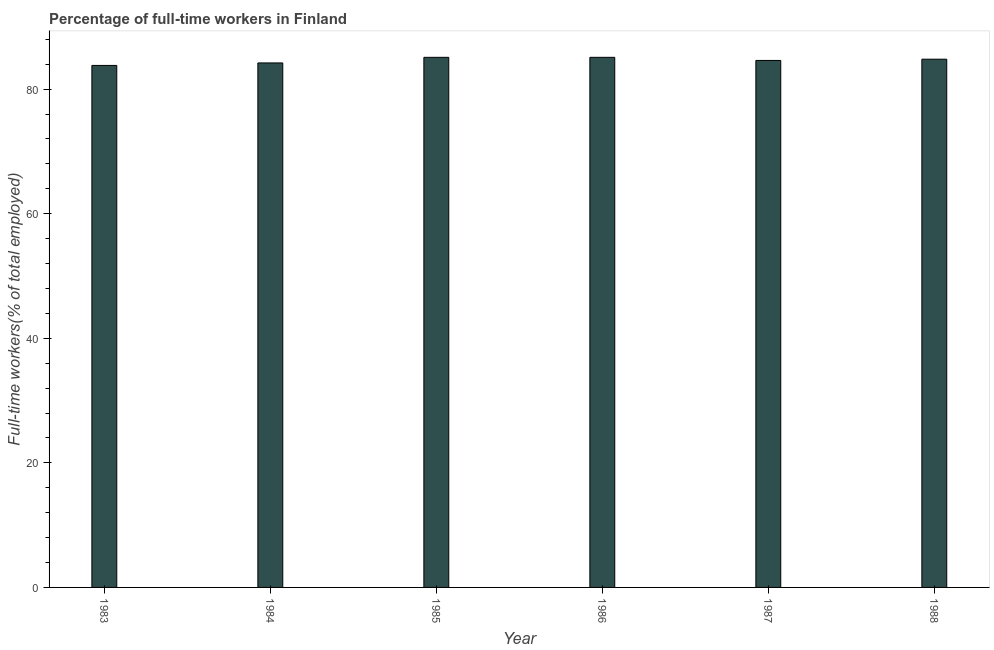What is the title of the graph?
Keep it short and to the point. Percentage of full-time workers in Finland. What is the label or title of the X-axis?
Offer a terse response. Year. What is the label or title of the Y-axis?
Your answer should be very brief. Full-time workers(% of total employed). What is the percentage of full-time workers in 1985?
Your response must be concise. 85.1. Across all years, what is the maximum percentage of full-time workers?
Your response must be concise. 85.1. Across all years, what is the minimum percentage of full-time workers?
Give a very brief answer. 83.8. In which year was the percentage of full-time workers maximum?
Make the answer very short. 1985. In which year was the percentage of full-time workers minimum?
Provide a short and direct response. 1983. What is the sum of the percentage of full-time workers?
Your response must be concise. 507.6. What is the average percentage of full-time workers per year?
Make the answer very short. 84.6. What is the median percentage of full-time workers?
Offer a terse response. 84.7. In how many years, is the percentage of full-time workers greater than 76 %?
Offer a very short reply. 6. Is the percentage of full-time workers in 1983 less than that in 1986?
Your answer should be compact. Yes. Is the difference between the percentage of full-time workers in 1983 and 1985 greater than the difference between any two years?
Ensure brevity in your answer.  Yes. What is the difference between the highest and the second highest percentage of full-time workers?
Keep it short and to the point. 0. Is the sum of the percentage of full-time workers in 1984 and 1988 greater than the maximum percentage of full-time workers across all years?
Give a very brief answer. Yes. In how many years, is the percentage of full-time workers greater than the average percentage of full-time workers taken over all years?
Give a very brief answer. 3. What is the difference between two consecutive major ticks on the Y-axis?
Offer a very short reply. 20. Are the values on the major ticks of Y-axis written in scientific E-notation?
Your response must be concise. No. What is the Full-time workers(% of total employed) in 1983?
Offer a very short reply. 83.8. What is the Full-time workers(% of total employed) of 1984?
Offer a very short reply. 84.2. What is the Full-time workers(% of total employed) in 1985?
Your answer should be very brief. 85.1. What is the Full-time workers(% of total employed) in 1986?
Provide a succinct answer. 85.1. What is the Full-time workers(% of total employed) in 1987?
Ensure brevity in your answer.  84.6. What is the Full-time workers(% of total employed) in 1988?
Offer a terse response. 84.8. What is the difference between the Full-time workers(% of total employed) in 1983 and 1984?
Provide a short and direct response. -0.4. What is the difference between the Full-time workers(% of total employed) in 1983 and 1985?
Your answer should be compact. -1.3. What is the difference between the Full-time workers(% of total employed) in 1983 and 1986?
Offer a very short reply. -1.3. What is the difference between the Full-time workers(% of total employed) in 1983 and 1987?
Offer a very short reply. -0.8. What is the difference between the Full-time workers(% of total employed) in 1983 and 1988?
Your answer should be compact. -1. What is the difference between the Full-time workers(% of total employed) in 1984 and 1985?
Provide a succinct answer. -0.9. What is the difference between the Full-time workers(% of total employed) in 1984 and 1986?
Your response must be concise. -0.9. What is the difference between the Full-time workers(% of total employed) in 1984 and 1987?
Ensure brevity in your answer.  -0.4. What is the difference between the Full-time workers(% of total employed) in 1984 and 1988?
Offer a terse response. -0.6. What is the difference between the Full-time workers(% of total employed) in 1985 and 1986?
Keep it short and to the point. 0. What is the difference between the Full-time workers(% of total employed) in 1985 and 1987?
Your answer should be compact. 0.5. What is the difference between the Full-time workers(% of total employed) in 1985 and 1988?
Keep it short and to the point. 0.3. What is the difference between the Full-time workers(% of total employed) in 1986 and 1988?
Offer a terse response. 0.3. What is the difference between the Full-time workers(% of total employed) in 1987 and 1988?
Provide a succinct answer. -0.2. What is the ratio of the Full-time workers(% of total employed) in 1983 to that in 1984?
Make the answer very short. 0.99. What is the ratio of the Full-time workers(% of total employed) in 1983 to that in 1987?
Your answer should be very brief. 0.99. What is the ratio of the Full-time workers(% of total employed) in 1983 to that in 1988?
Your answer should be compact. 0.99. What is the ratio of the Full-time workers(% of total employed) in 1984 to that in 1988?
Provide a short and direct response. 0.99. What is the ratio of the Full-time workers(% of total employed) in 1985 to that in 1986?
Provide a short and direct response. 1. What is the ratio of the Full-time workers(% of total employed) in 1985 to that in 1988?
Provide a succinct answer. 1. What is the ratio of the Full-time workers(% of total employed) in 1986 to that in 1988?
Ensure brevity in your answer.  1. What is the ratio of the Full-time workers(% of total employed) in 1987 to that in 1988?
Your answer should be compact. 1. 